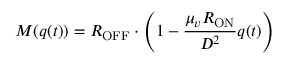Convert formula to latex. <formula><loc_0><loc_0><loc_500><loc_500>M ( q ( t ) ) = R _ { O F F } \cdot \left ( 1 - { \frac { \mu _ { v } R _ { O N } } { D ^ { 2 } } } q ( t ) \right )</formula> 